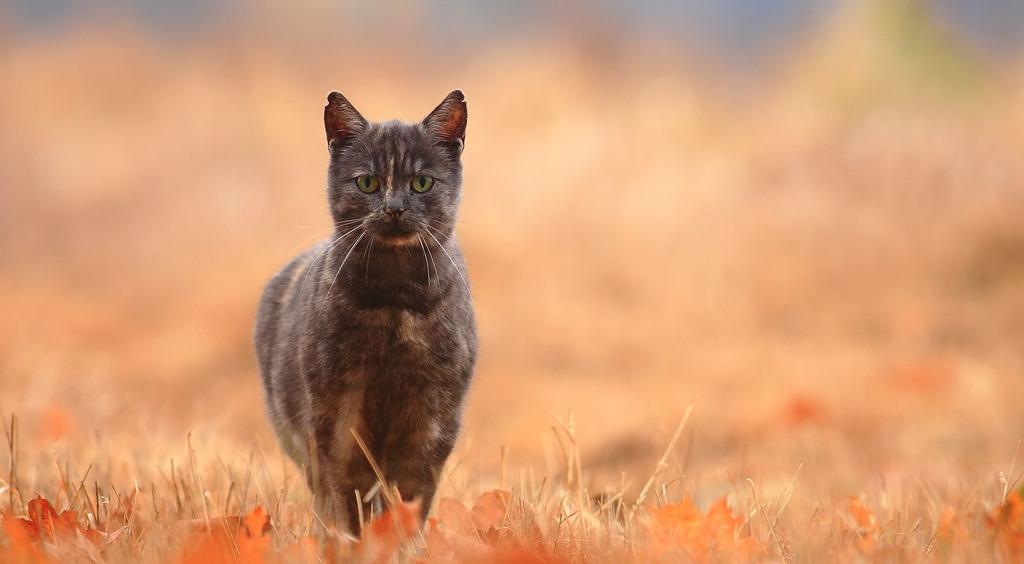Can you describe this image briefly? In this image we can see a cat and there is a grass and leaves on the ground and a blurry background. 